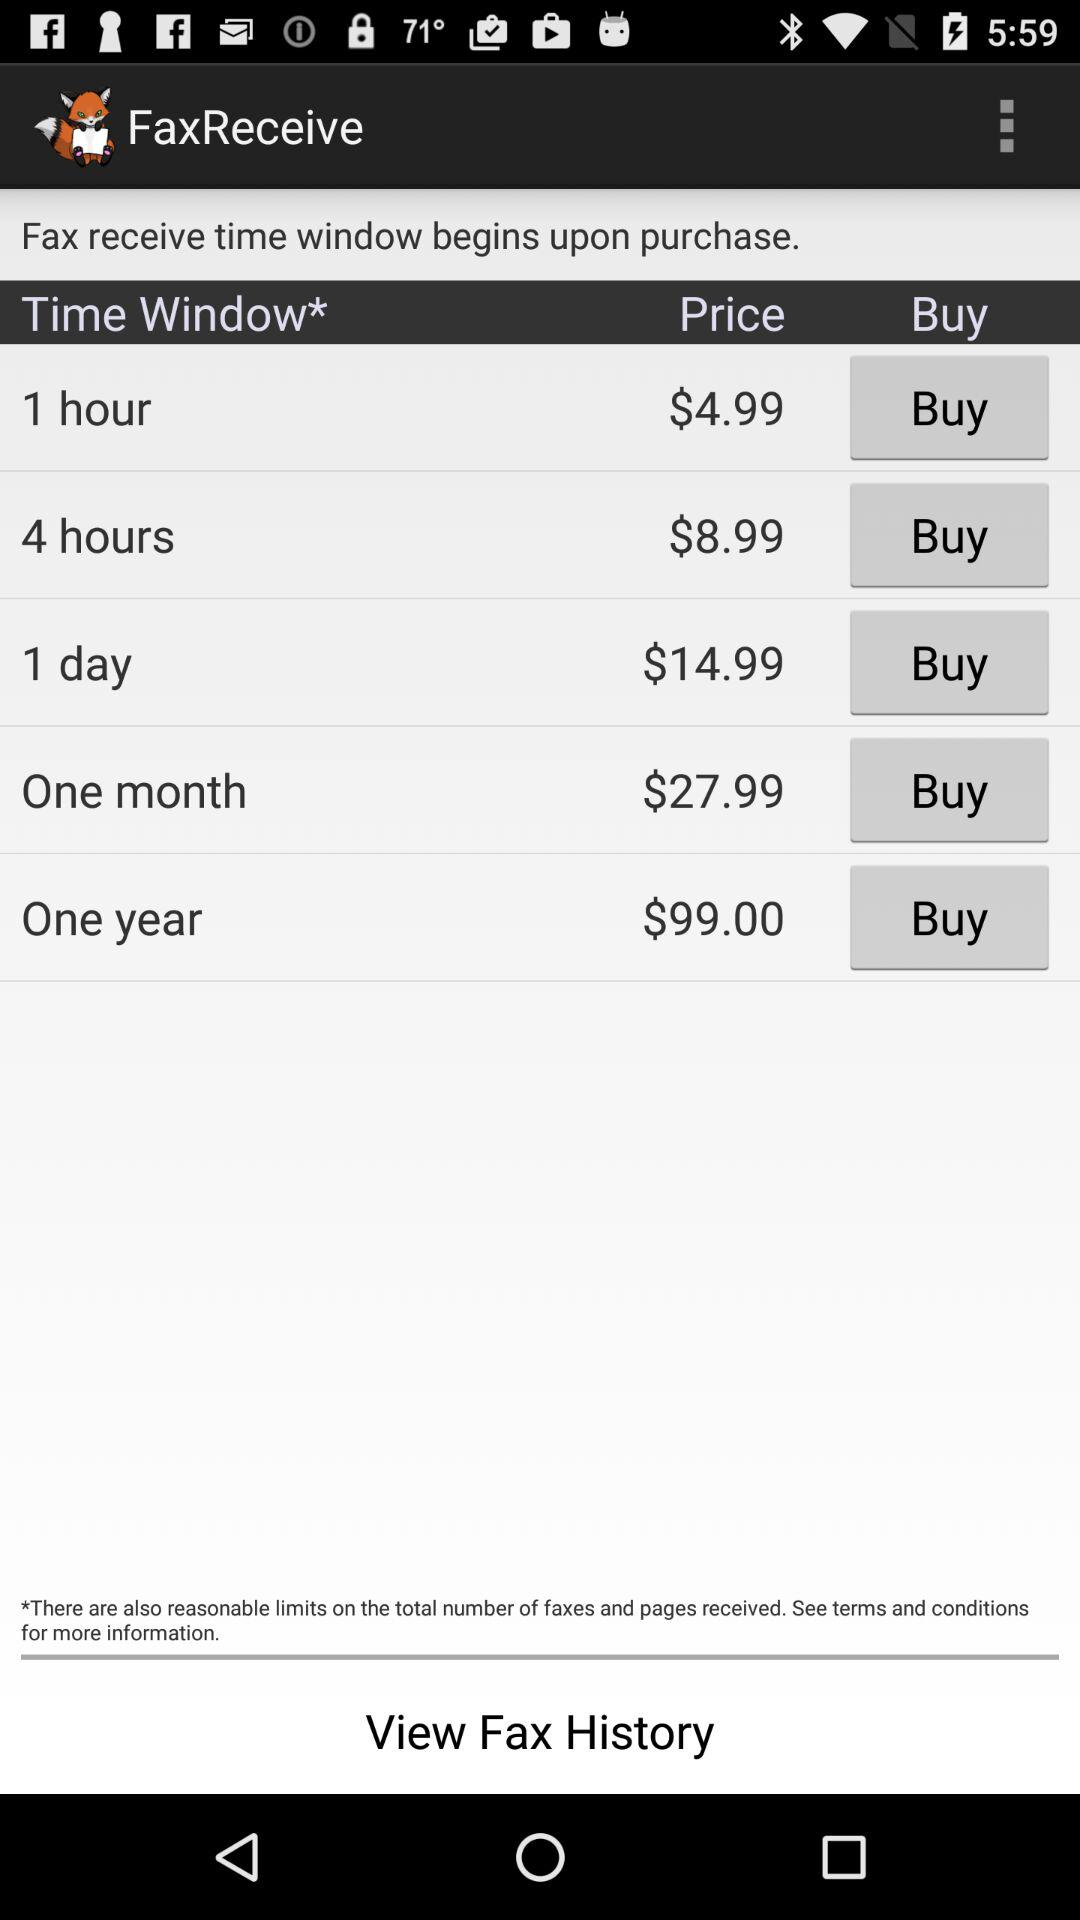What is the price of a 1 day time window? The price is $14.99. 